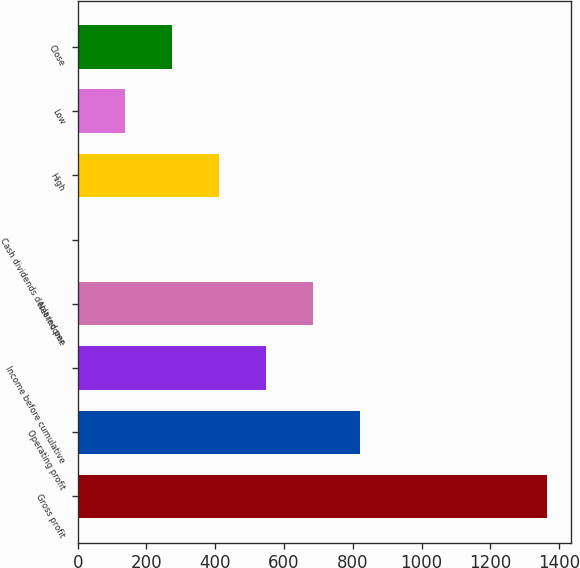Convert chart. <chart><loc_0><loc_0><loc_500><loc_500><bar_chart><fcel>Gross profit<fcel>Operating profit<fcel>Income before cumulative<fcel>Net income<fcel>Cash dividends declared per<fcel>High<fcel>Low<fcel>Close<nl><fcel>1365.9<fcel>819.73<fcel>546.65<fcel>683.19<fcel>0.49<fcel>410.11<fcel>137.03<fcel>273.57<nl></chart> 